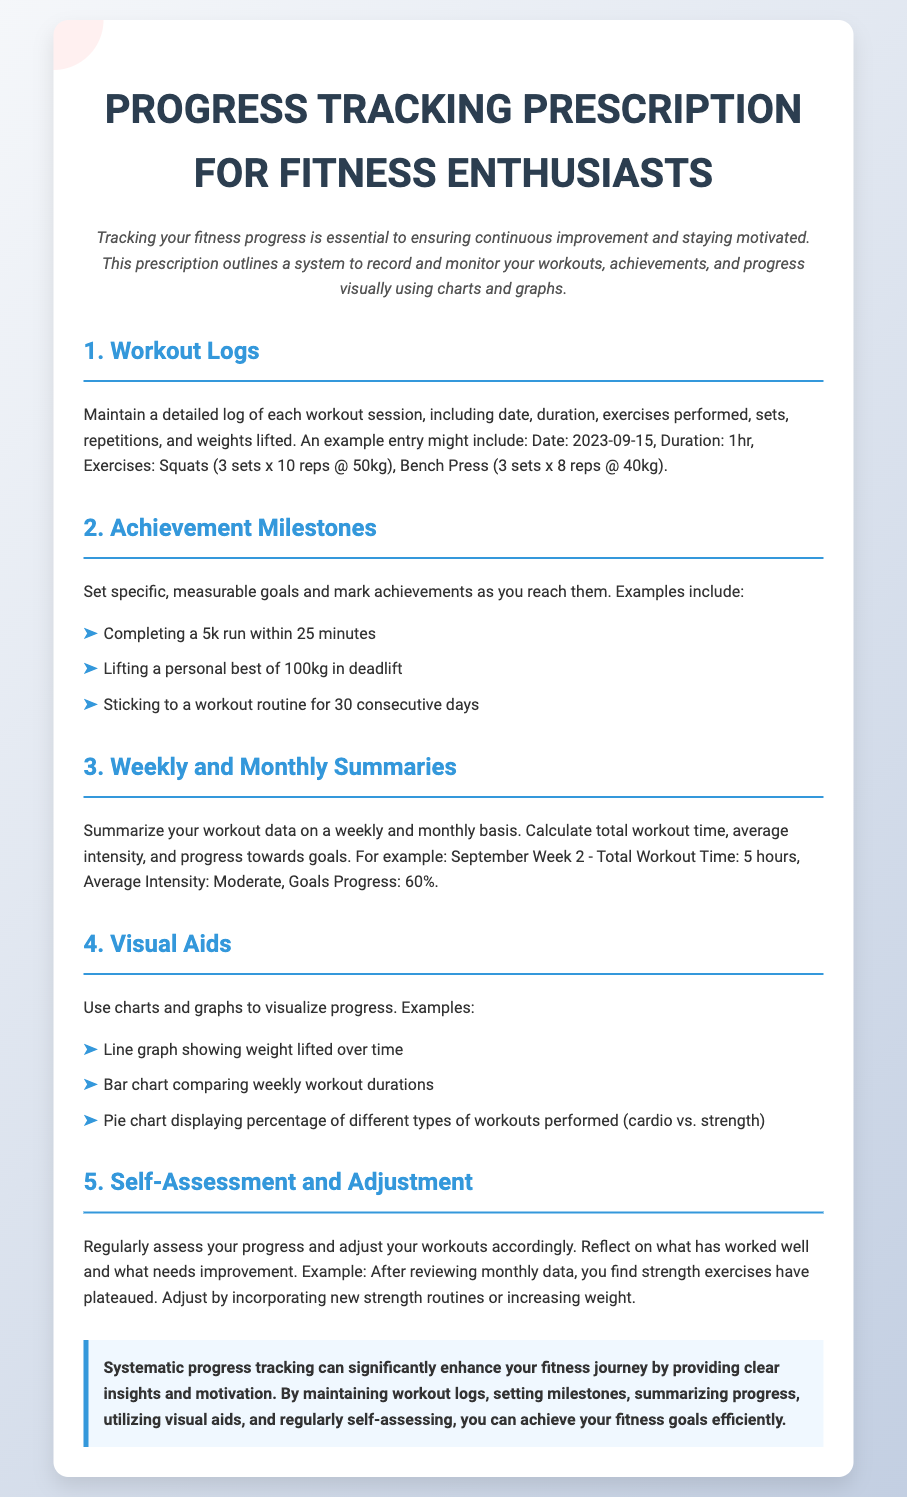What is the title of the document? The title of the document is specified in the <title> tag and at the top of the content.
Answer: Progress Tracking Prescription for Fitness Enthusiasts What should be included in a workout log? The document lists several components that should be recorded in a workout log.
Answer: Date, duration, exercises, sets, repetitions, and weights lifted What is an example of an achievement milestone mentioned? The document provides a list of specific examples under achievement milestones.
Answer: Completing a 5k run within 25 minutes What is the average intensity mentioned in the weekly summary example? The document gives an example of what the average intensity can be in a summary.
Answer: Moderate What type of chart is suggested for visualizing weight lifted over time? The document specifically mentions a type of graph for tracking weight lifting progress.
Answer: Line graph How often should progress be assessed according to the document? The document suggests conducting assessments at regular intervals.
Answer: Regularly What visual aid type displays a percentage of different types of workouts? The document describes a specific chart type for comparing workout types.
Answer: Pie chart What color is used for the prescription background? The color of the prescription background is explicitly described in the styling section of the document.
Answer: White What key method is highlighted for maintaining motivation? The document emphasizes a systematic approach to enhance one's fitness journey.
Answer: Systematic progress tracking 